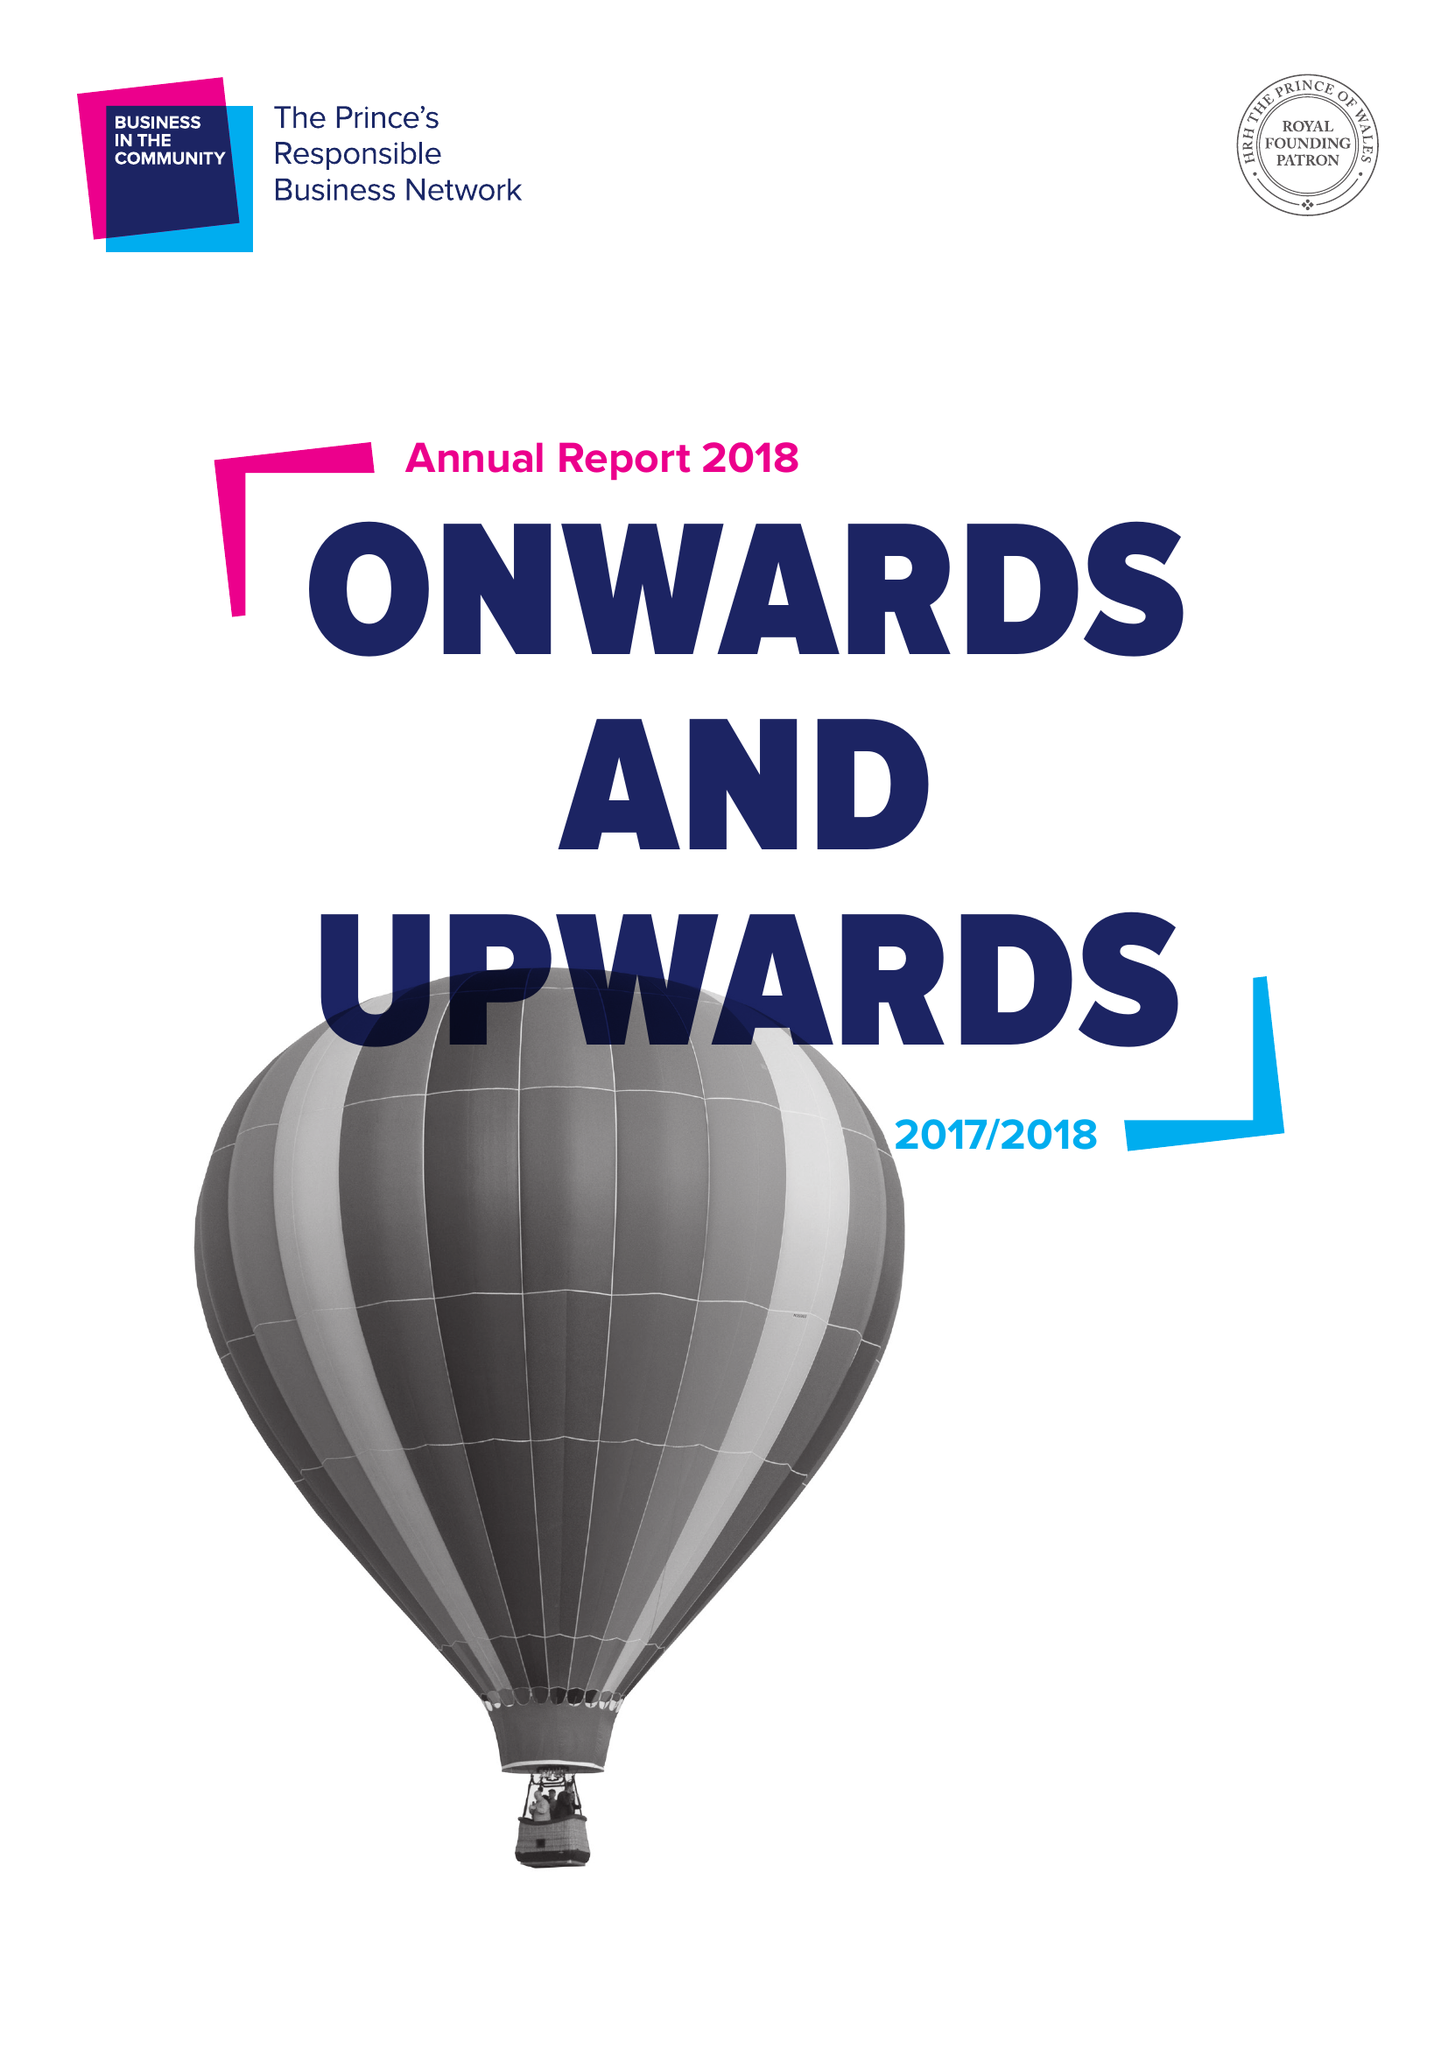What is the value for the address__street_line?
Answer the question using a single word or phrase. 137 SHEPHERDESS WALK 